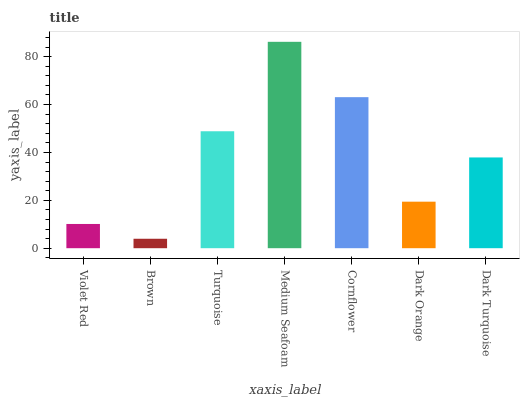Is Brown the minimum?
Answer yes or no. Yes. Is Medium Seafoam the maximum?
Answer yes or no. Yes. Is Turquoise the minimum?
Answer yes or no. No. Is Turquoise the maximum?
Answer yes or no. No. Is Turquoise greater than Brown?
Answer yes or no. Yes. Is Brown less than Turquoise?
Answer yes or no. Yes. Is Brown greater than Turquoise?
Answer yes or no. No. Is Turquoise less than Brown?
Answer yes or no. No. Is Dark Turquoise the high median?
Answer yes or no. Yes. Is Dark Turquoise the low median?
Answer yes or no. Yes. Is Violet Red the high median?
Answer yes or no. No. Is Cornflower the low median?
Answer yes or no. No. 